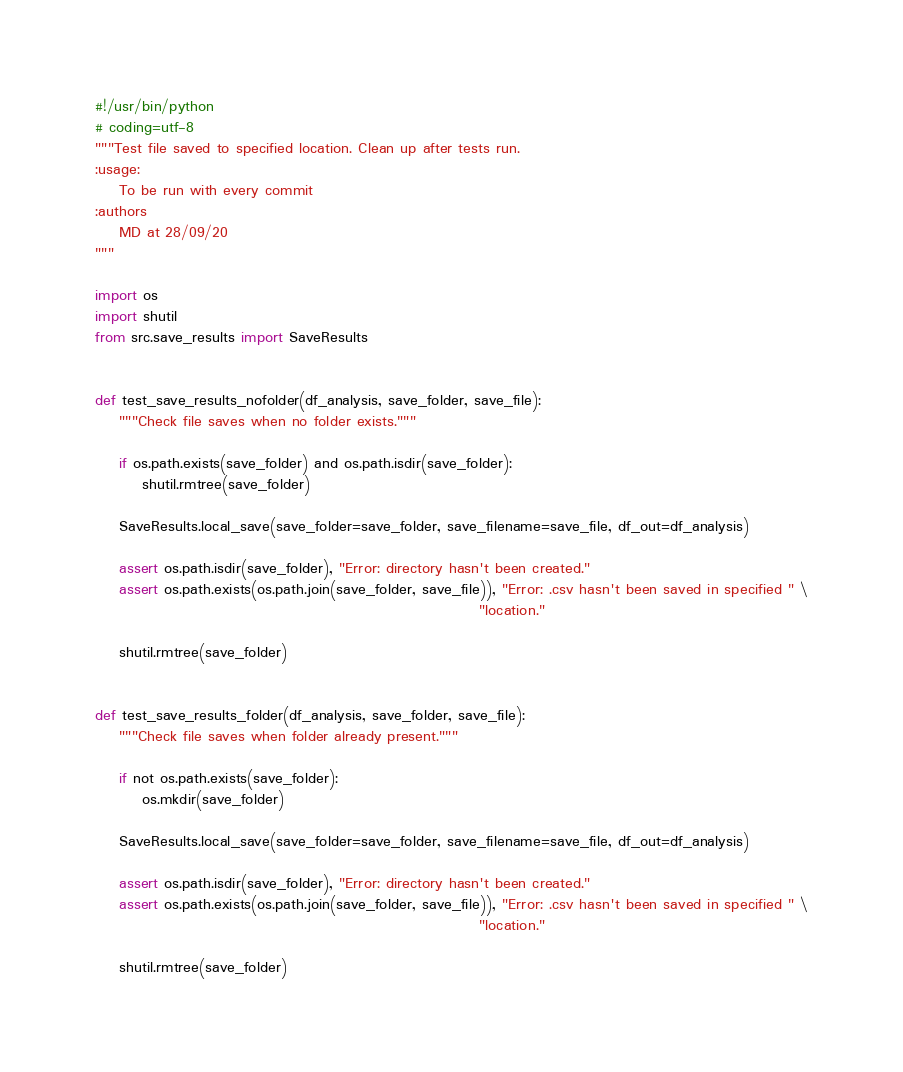Convert code to text. <code><loc_0><loc_0><loc_500><loc_500><_Python_>#!/usr/bin/python
# coding=utf-8
"""Test file saved to specified location. Clean up after tests run.
:usage:
    To be run with every commit
:authors
    MD at 28/09/20
"""

import os
import shutil
from src.save_results import SaveResults


def test_save_results_nofolder(df_analysis, save_folder, save_file):
    """Check file saves when no folder exists."""

    if os.path.exists(save_folder) and os.path.isdir(save_folder):
        shutil.rmtree(save_folder)

    SaveResults.local_save(save_folder=save_folder, save_filename=save_file, df_out=df_analysis)

    assert os.path.isdir(save_folder), "Error: directory hasn't been created."
    assert os.path.exists(os.path.join(save_folder, save_file)), "Error: .csv hasn't been saved in specified " \
                                                                 "location."

    shutil.rmtree(save_folder)


def test_save_results_folder(df_analysis, save_folder, save_file):
    """Check file saves when folder already present."""

    if not os.path.exists(save_folder):
        os.mkdir(save_folder)

    SaveResults.local_save(save_folder=save_folder, save_filename=save_file, df_out=df_analysis)

    assert os.path.isdir(save_folder), "Error: directory hasn't been created."
    assert os.path.exists(os.path.join(save_folder, save_file)), "Error: .csv hasn't been saved in specified " \
                                                                 "location."

    shutil.rmtree(save_folder)
</code> 